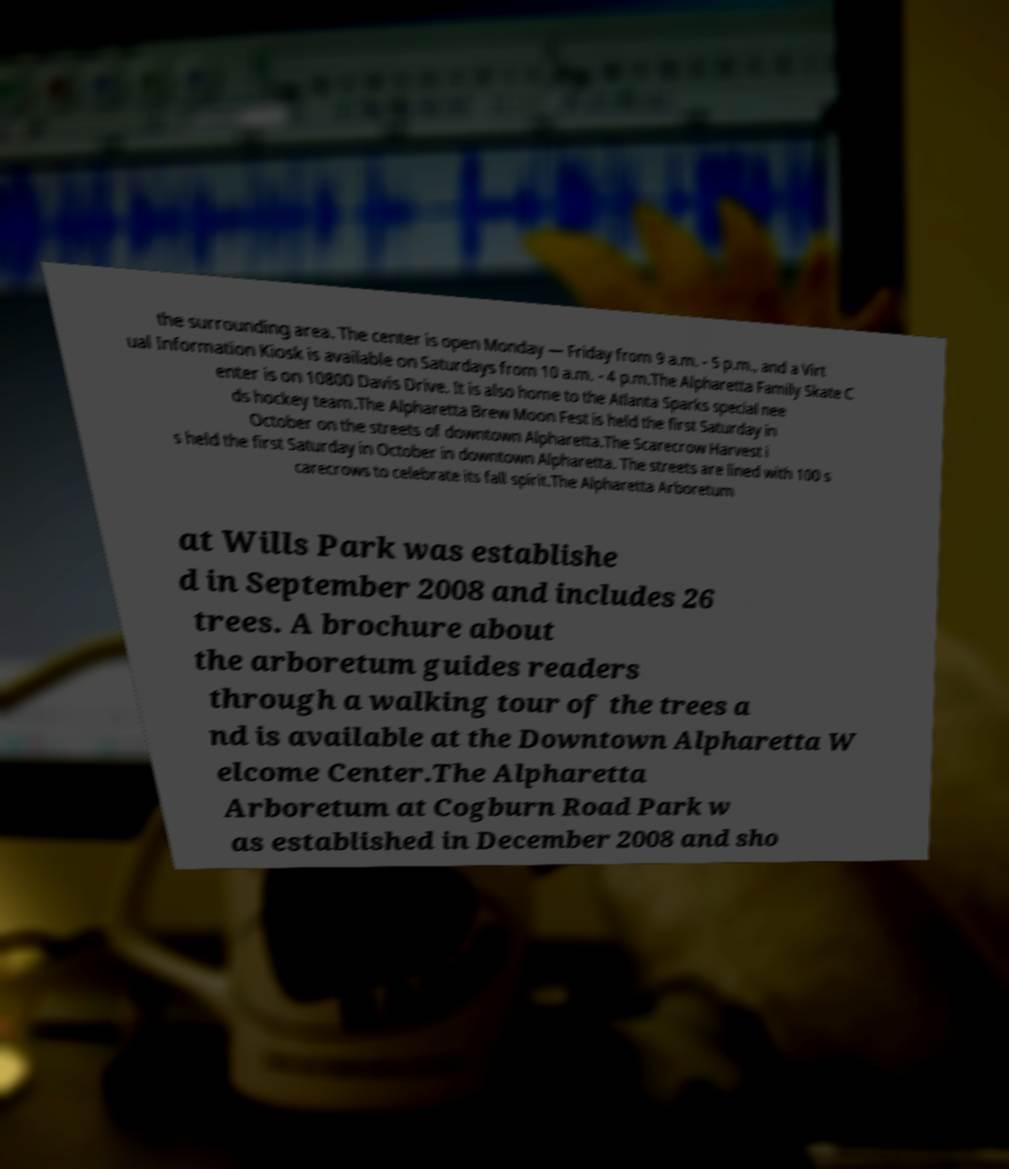Could you assist in decoding the text presented in this image and type it out clearly? the surrounding area. The center is open Monday — Friday from 9 a.m. - 5 p.m., and a Virt ual Information Kiosk is available on Saturdays from 10 a.m. - 4 p.m.The Alpharetta Family Skate C enter is on 10800 Davis Drive. It is also home to the Atlanta Sparks special nee ds hockey team.The Alpharetta Brew Moon Fest is held the first Saturday in October on the streets of downtown Alpharetta.The Scarecrow Harvest i s held the first Saturday in October in downtown Alpharetta. The streets are lined with 100 s carecrows to celebrate its fall spirit.The Alpharetta Arboretum at Wills Park was establishe d in September 2008 and includes 26 trees. A brochure about the arboretum guides readers through a walking tour of the trees a nd is available at the Downtown Alpharetta W elcome Center.The Alpharetta Arboretum at Cogburn Road Park w as established in December 2008 and sho 